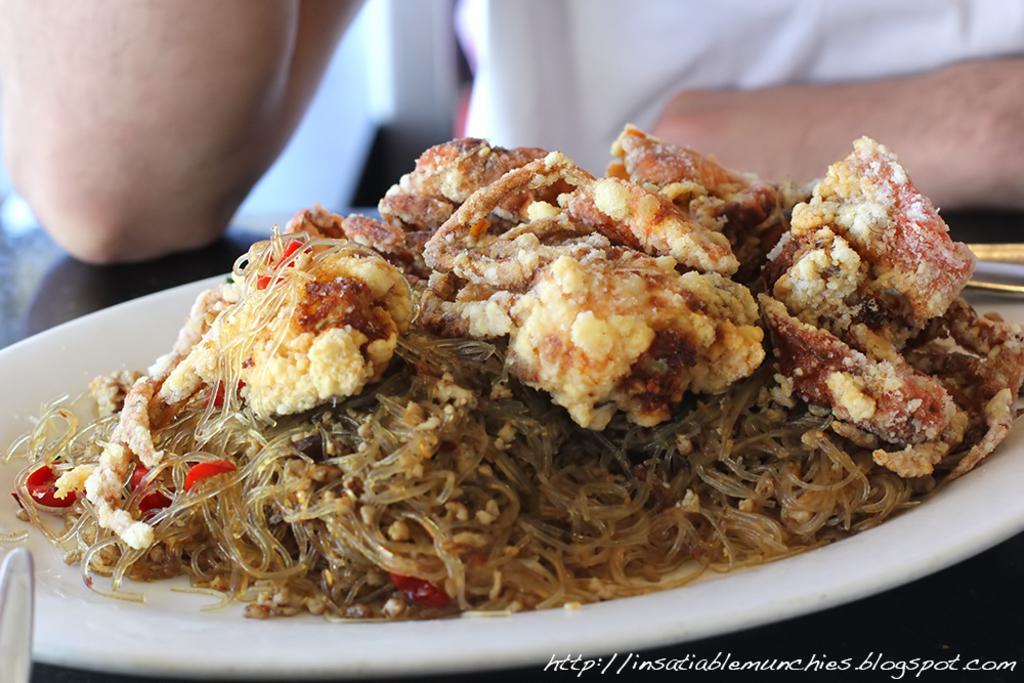Could you give a brief overview of what you see in this image? In this image I can see a plate, food, table and a person's hands. At the bottom right side of the image there is a watermark.   